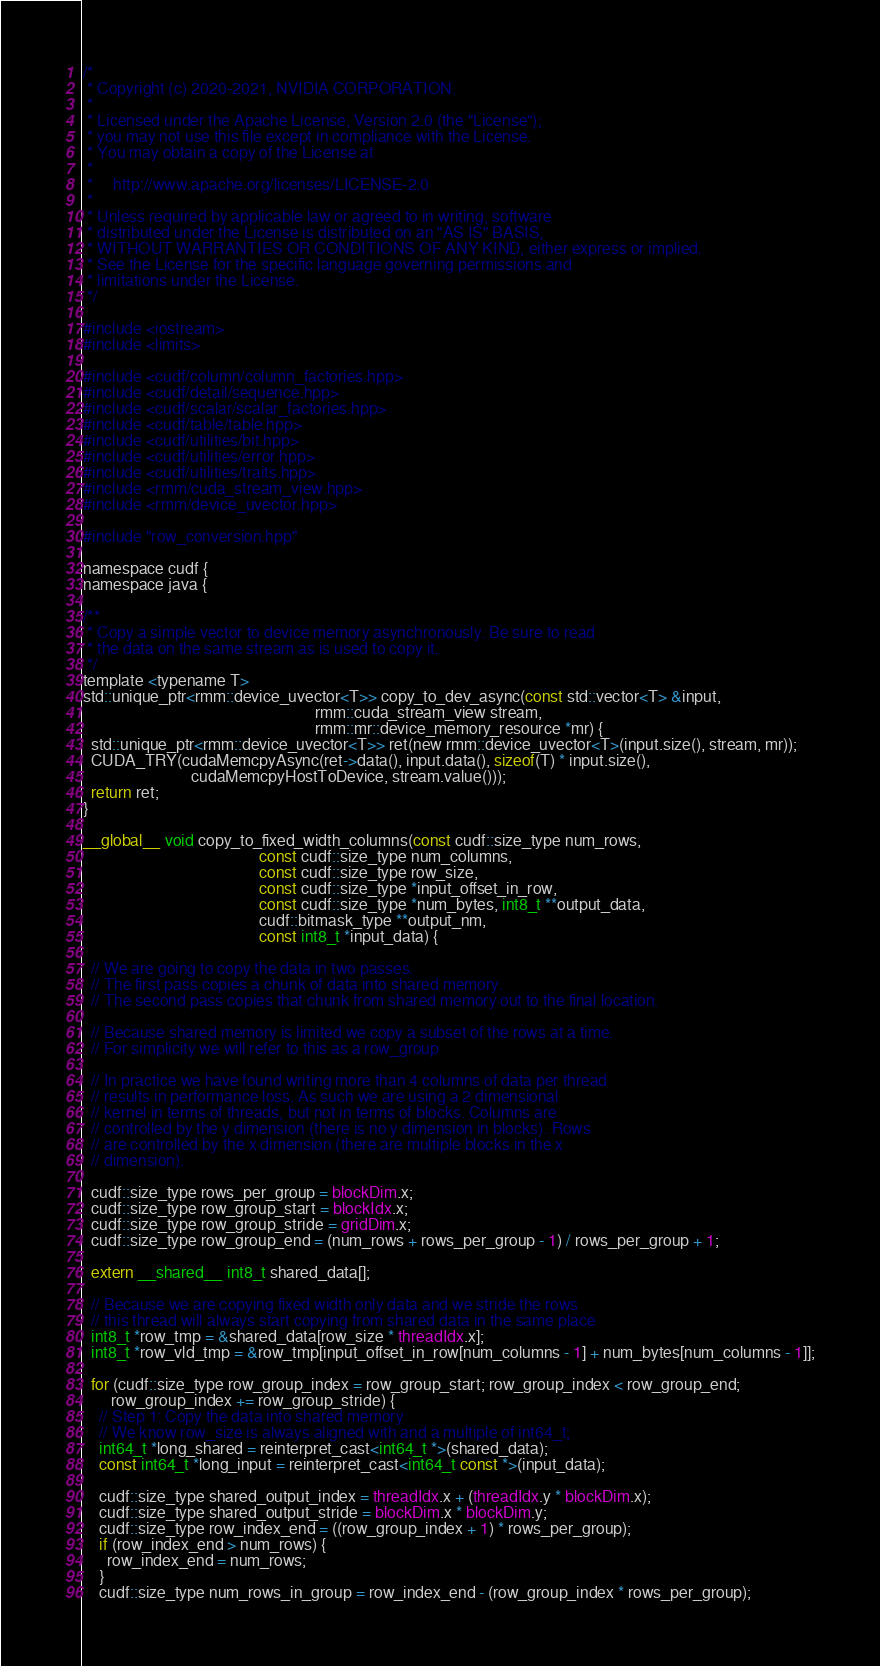<code> <loc_0><loc_0><loc_500><loc_500><_Cuda_>/*
 * Copyright (c) 2020-2021, NVIDIA CORPORATION.
 *
 * Licensed under the Apache License, Version 2.0 (the "License");
 * you may not use this file except in compliance with the License.
 * You may obtain a copy of the License at
 *
 *     http://www.apache.org/licenses/LICENSE-2.0
 *
 * Unless required by applicable law or agreed to in writing, software
 * distributed under the License is distributed on an "AS IS" BASIS,
 * WITHOUT WARRANTIES OR CONDITIONS OF ANY KIND, either express or implied.
 * See the License for the specific language governing permissions and
 * limitations under the License.
 */

#include <iostream>
#include <limits>

#include <cudf/column/column_factories.hpp>
#include <cudf/detail/sequence.hpp>
#include <cudf/scalar/scalar_factories.hpp>
#include <cudf/table/table.hpp>
#include <cudf/utilities/bit.hpp>
#include <cudf/utilities/error.hpp>
#include <cudf/utilities/traits.hpp>
#include <rmm/cuda_stream_view.hpp>
#include <rmm/device_uvector.hpp>

#include "row_conversion.hpp"

namespace cudf {
namespace java {

/**
 * Copy a simple vector to device memory asynchronously. Be sure to read
 * the data on the same stream as is used to copy it.
 */
template <typename T>
std::unique_ptr<rmm::device_uvector<T>> copy_to_dev_async(const std::vector<T> &input,
                                                          rmm::cuda_stream_view stream,
                                                          rmm::mr::device_memory_resource *mr) {
  std::unique_ptr<rmm::device_uvector<T>> ret(new rmm::device_uvector<T>(input.size(), stream, mr));
  CUDA_TRY(cudaMemcpyAsync(ret->data(), input.data(), sizeof(T) * input.size(),
                           cudaMemcpyHostToDevice, stream.value()));
  return ret;
}

__global__ void copy_to_fixed_width_columns(const cudf::size_type num_rows,
                                            const cudf::size_type num_columns,
                                            const cudf::size_type row_size,
                                            const cudf::size_type *input_offset_in_row,
                                            const cudf::size_type *num_bytes, int8_t **output_data,
                                            cudf::bitmask_type **output_nm,
                                            const int8_t *input_data) {

  // We are going to copy the data in two passes.
  // The first pass copies a chunk of data into shared memory.
  // The second pass copies that chunk from shared memory out to the final location.

  // Because shared memory is limited we copy a subset of the rows at a time.
  // For simplicity we will refer to this as a row_group

  // In practice we have found writing more than 4 columns of data per thread
  // results in performance loss. As such we are using a 2 dimensional
  // kernel in terms of threads, but not in terms of blocks. Columns are
  // controlled by the y dimension (there is no y dimension in blocks). Rows
  // are controlled by the x dimension (there are multiple blocks in the x
  // dimension).

  cudf::size_type rows_per_group = blockDim.x;
  cudf::size_type row_group_start = blockIdx.x;
  cudf::size_type row_group_stride = gridDim.x;
  cudf::size_type row_group_end = (num_rows + rows_per_group - 1) / rows_per_group + 1;

  extern __shared__ int8_t shared_data[];

  // Because we are copying fixed width only data and we stride the rows
  // this thread will always start copying from shared data in the same place
  int8_t *row_tmp = &shared_data[row_size * threadIdx.x];
  int8_t *row_vld_tmp = &row_tmp[input_offset_in_row[num_columns - 1] + num_bytes[num_columns - 1]];

  for (cudf::size_type row_group_index = row_group_start; row_group_index < row_group_end;
       row_group_index += row_group_stride) {
    // Step 1: Copy the data into shared memory
    // We know row_size is always aligned with and a multiple of int64_t;
    int64_t *long_shared = reinterpret_cast<int64_t *>(shared_data);
    const int64_t *long_input = reinterpret_cast<int64_t const *>(input_data);

    cudf::size_type shared_output_index = threadIdx.x + (threadIdx.y * blockDim.x);
    cudf::size_type shared_output_stride = blockDim.x * blockDim.y;
    cudf::size_type row_index_end = ((row_group_index + 1) * rows_per_group);
    if (row_index_end > num_rows) {
      row_index_end = num_rows;
    }
    cudf::size_type num_rows_in_group = row_index_end - (row_group_index * rows_per_group);</code> 